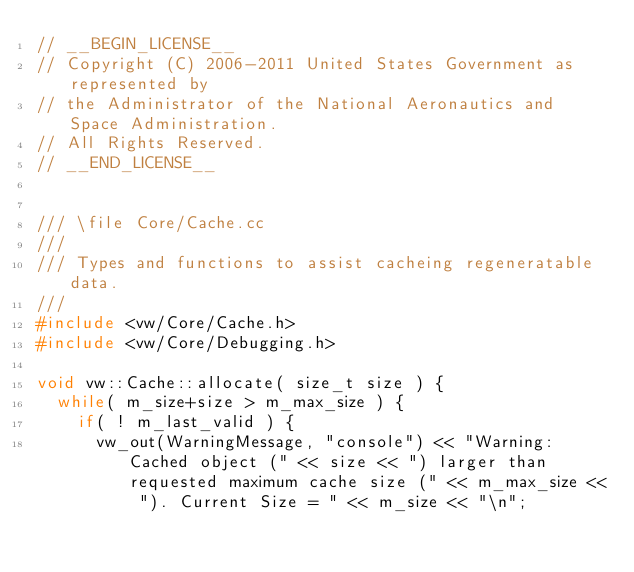<code> <loc_0><loc_0><loc_500><loc_500><_C++_>// __BEGIN_LICENSE__
// Copyright (C) 2006-2011 United States Government as represented by
// the Administrator of the National Aeronautics and Space Administration.
// All Rights Reserved.
// __END_LICENSE__


/// \file Core/Cache.cc
///
/// Types and functions to assist cacheing regeneratable data.
///
#include <vw/Core/Cache.h>
#include <vw/Core/Debugging.h>

void vw::Cache::allocate( size_t size ) {
  while( m_size+size > m_max_size ) {
    if( ! m_last_valid ) {
      vw_out(WarningMessage, "console") << "Warning: Cached object (" << size << ") larger than requested maximum cache size (" << m_max_size << "). Current Size = " << m_size << "\n";</code> 